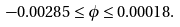<formula> <loc_0><loc_0><loc_500><loc_500>- 0 . 0 0 2 8 5 \leq \phi \leq 0 . 0 0 0 1 8 .</formula> 